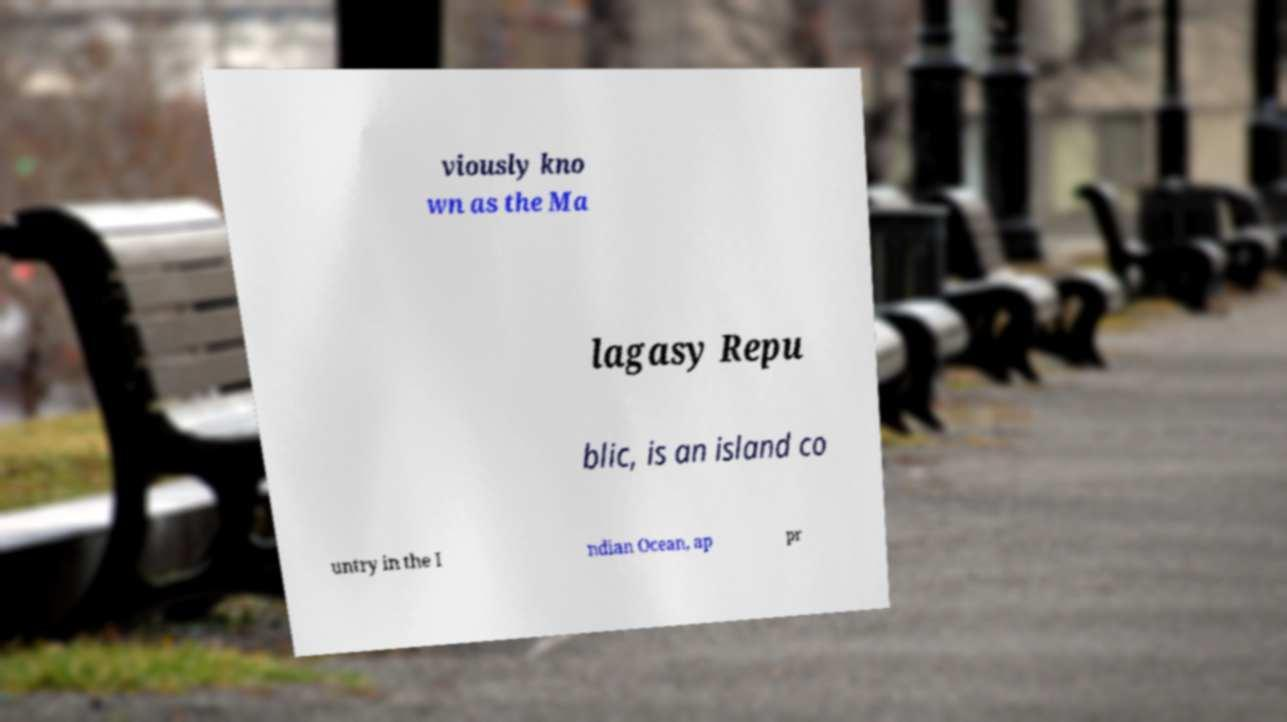Could you extract and type out the text from this image? viously kno wn as the Ma lagasy Repu blic, is an island co untry in the I ndian Ocean, ap pr 